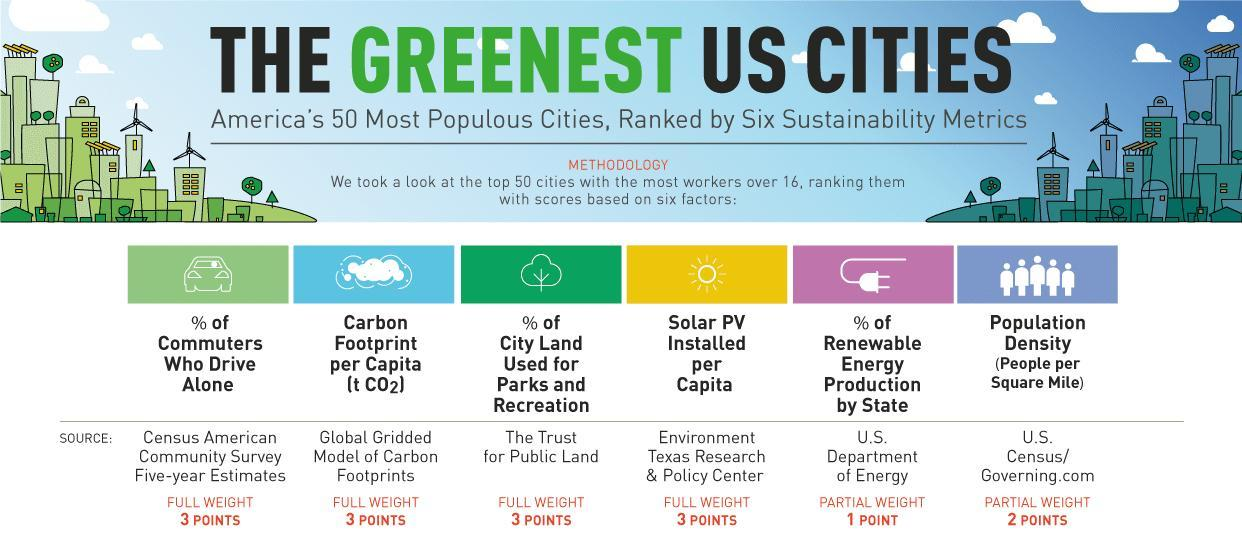From which source has the land use for park and recreation taken from?
Answer the question with a short phrase. The Trust for Public Land What is the weightage given for population density? 2 POINTS 